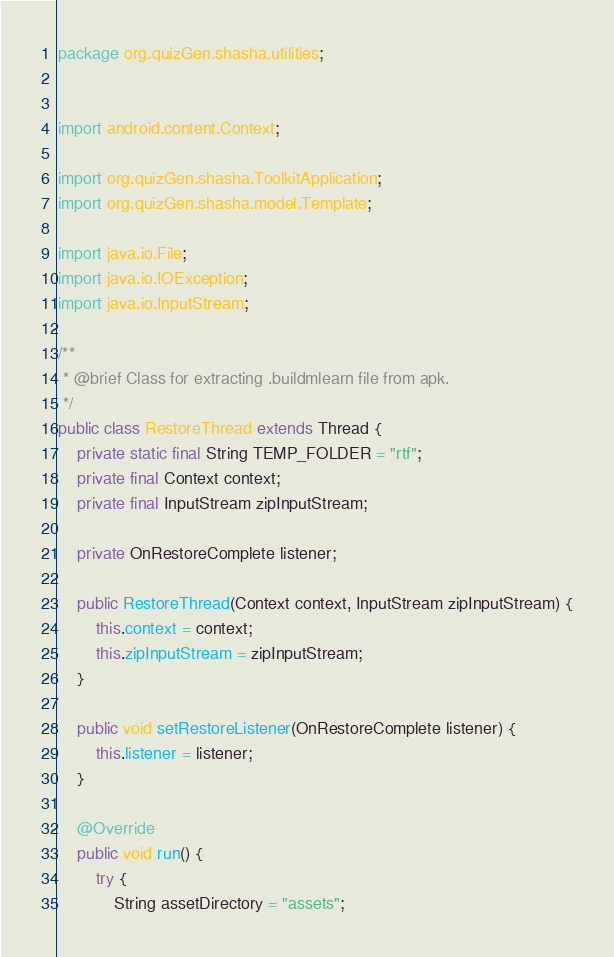<code> <loc_0><loc_0><loc_500><loc_500><_Java_>package org.quizGen.shasha.utilities;


import android.content.Context;

import org.quizGen.shasha.ToolkitApplication;
import org.quizGen.shasha.model.Template;

import java.io.File;
import java.io.IOException;
import java.io.InputStream;

/**
 * @brief Class for extracting .buildmlearn file from apk.
 */
public class RestoreThread extends Thread {
    private static final String TEMP_FOLDER = "rtf";
    private final Context context;
    private final InputStream zipInputStream;

    private OnRestoreComplete listener;

    public RestoreThread(Context context, InputStream zipInputStream) {
        this.context = context;
        this.zipInputStream = zipInputStream;
    }

    public void setRestoreListener(OnRestoreComplete listener) {
        this.listener = listener;
    }

    @Override
    public void run() {
        try {
            String assetDirectory = "assets";</code> 